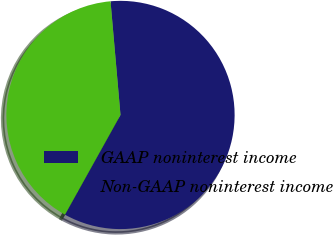Convert chart to OTSL. <chart><loc_0><loc_0><loc_500><loc_500><pie_chart><fcel>GAAP noninterest income<fcel>Non-GAAP noninterest income<nl><fcel>59.48%<fcel>40.52%<nl></chart> 